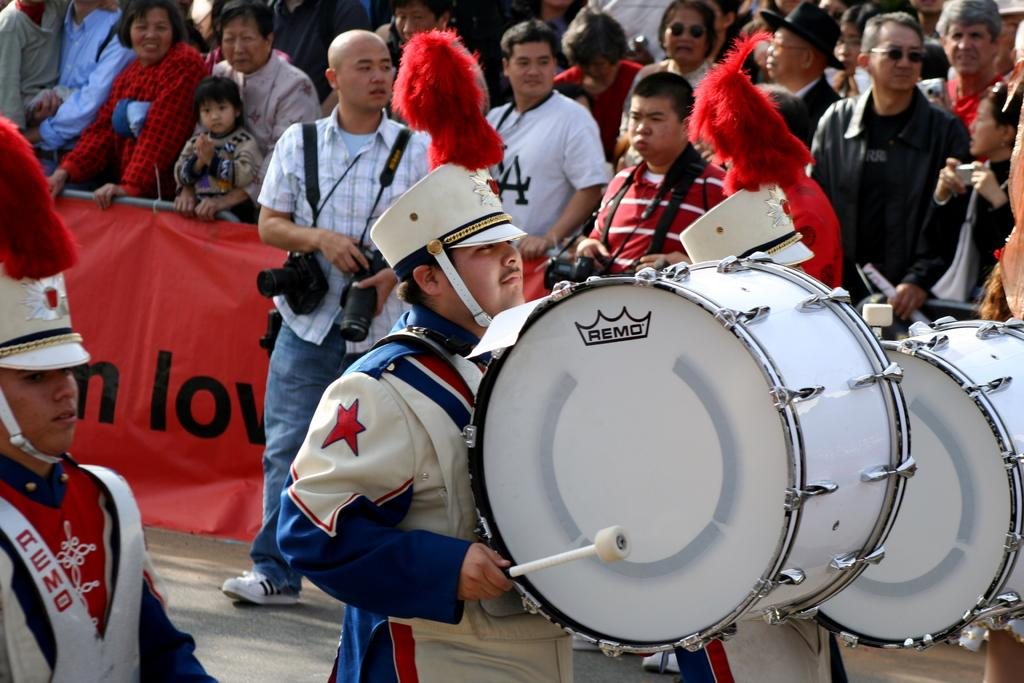What is the man in the image doing? The man is walking on the road and playing a drum in his hand. Can you describe the photographer in the background? There is a photographer in the background, but no specific details about the photographer are provided. What are the people behind the railing cloth doing? Some people are standing behind a railing cloth, watching the man. What type of neck accessory is the man wearing in the image? There is no mention of a neck accessory in the image; the man is playing a drum while walking on the road. What is the man rubbing on his leg in the image? There is no indication in the image that the man is rubbing anything on his leg. 